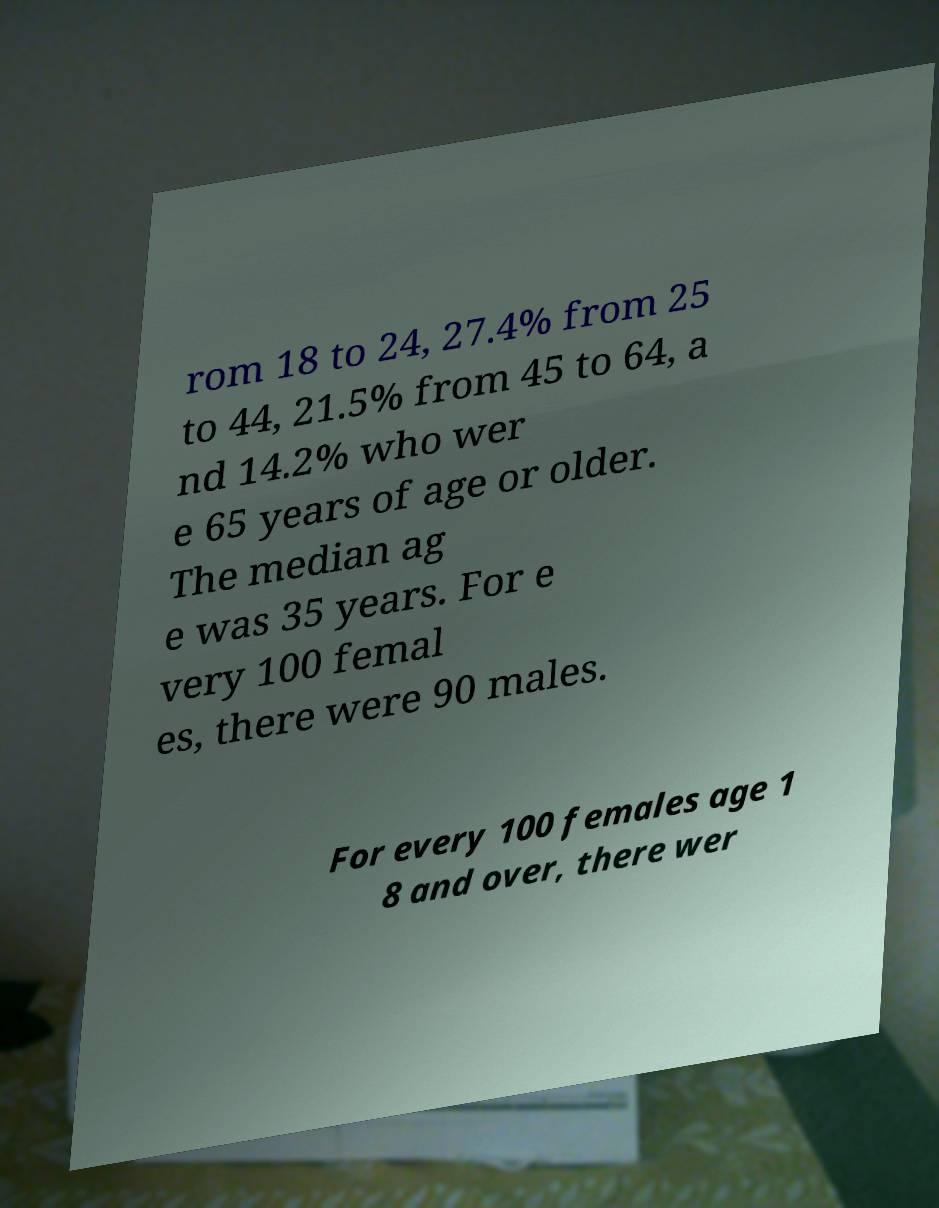There's text embedded in this image that I need extracted. Can you transcribe it verbatim? rom 18 to 24, 27.4% from 25 to 44, 21.5% from 45 to 64, a nd 14.2% who wer e 65 years of age or older. The median ag e was 35 years. For e very 100 femal es, there were 90 males. For every 100 females age 1 8 and over, there wer 